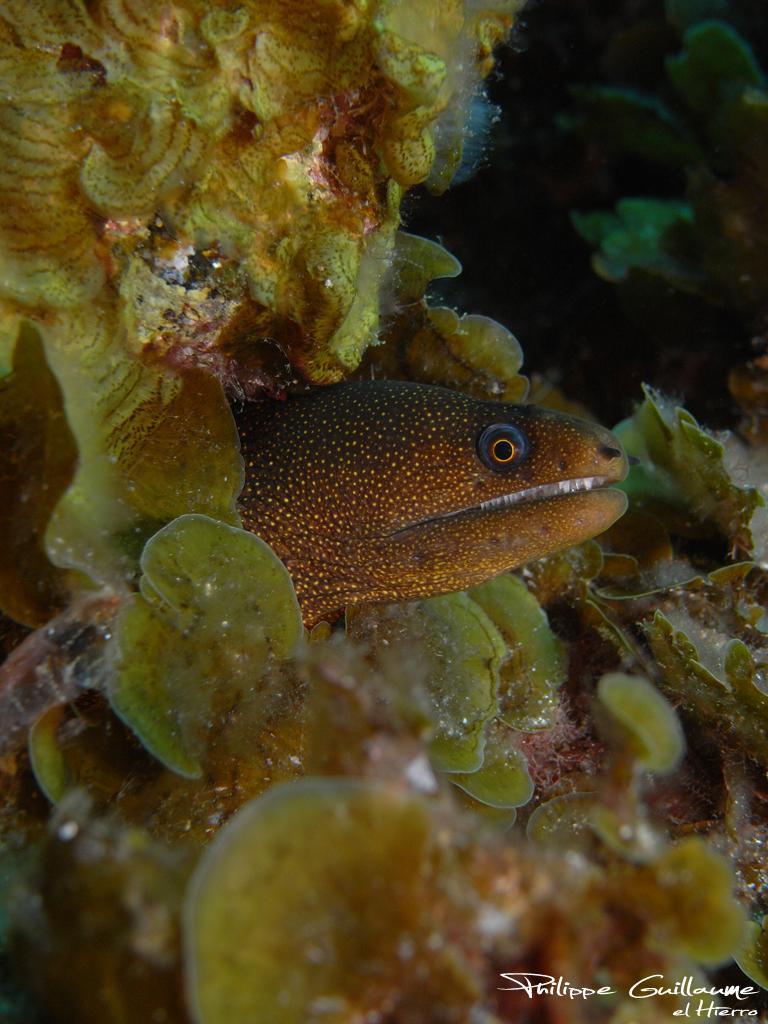Please provide a concise description of this image. In this image we can see a fish with an underwater environment. 